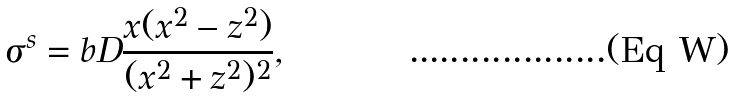Convert formula to latex. <formula><loc_0><loc_0><loc_500><loc_500>\sigma ^ { s } = b D \frac { x ( x ^ { 2 } - z ^ { 2 } ) } { ( x ^ { 2 } + z ^ { 2 } ) ^ { 2 } } ,</formula> 